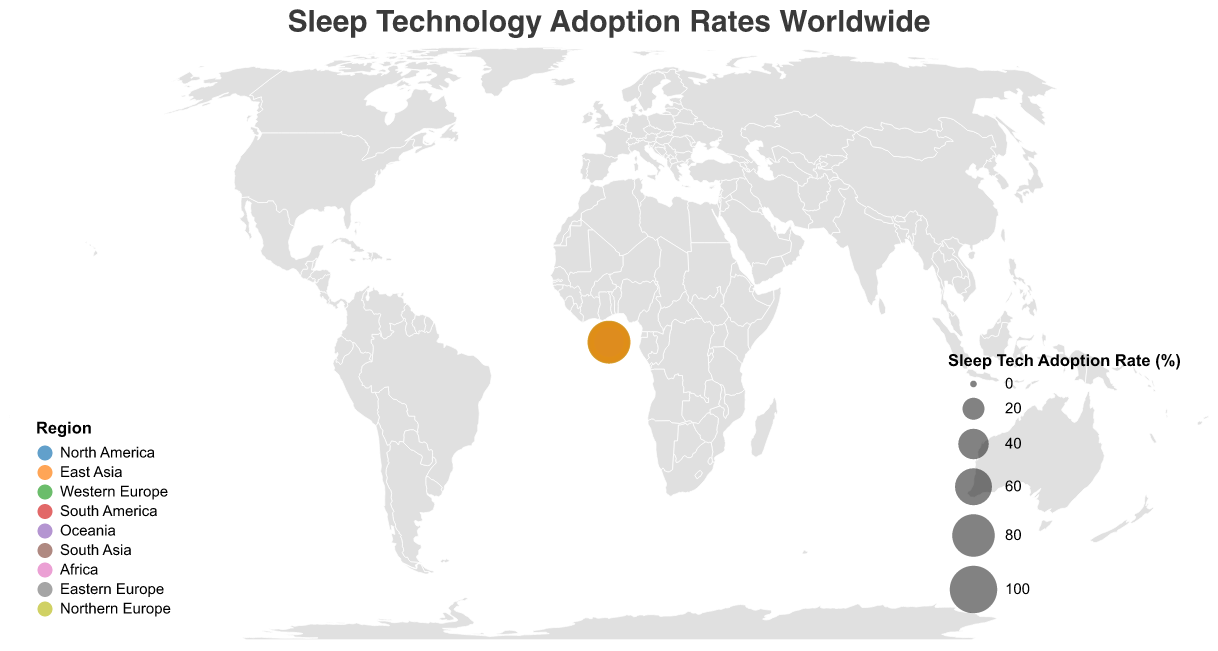What is the title of the figure? The title is located at the top of the figure and defines the main subject of the data visualization.
Answer: Sleep Technology Adoption Rates Worldwide Which country has the lowest sleep tech adoption rate? From the figure, identify the country with the smallest circle, as the size of the circle represents the adoption rate.
Answer: South Africa What is the most popular therapy in Japan? Hover or look at the tooltip for Japan displayed on the figure. It indicates the most popular therapy in that specific country.
Answer: Light Therapy How does the sleep tech adoption rate in the United States compare to that in Canada? Compare the size of the circles representing the United States and Canada, or directly compare the adoption rate values from the tooltips. The rates are 78% for the US and 75% for Canada.
Answer: The United States has a slightly higher adoption rate than Canada What is the average sleep tech adoption rate in Western Europe? Calculate the average by summing the adoption rates of Germany (65%), United Kingdom (72%), and France (68%) and dividing by the number of countries. (65 + 72 + 68) / 3 = 205 / 3
Answer: 68.33% Which region has the highest overall sleep tech adoption rate and which country in that region drives this rate? Identify the region with the highest adoption rate by examining the size of the circles relative to their colors. East Asia has the highest overall rates driven primarily by Japan (82%).
Answer: East Asia, driven by Japan Compare the sleep tech adoption rates between the largest and smallest circles on the map. The largest circle represents Japan with an 82% adoption rate, and the smallest circle represents South Africa with a 28% adoption rate. To compare, simply subtract the smaller rate from the larger one: 82% - 28%.
Answer: There is a 54% difference Which therapy is most popular in Western Europe and how many countries in that region prefer different therapies? Hover over the countries in Western Europe and note the most popular therapies. Germany prefers Biofeedback, the United Kingdom prefers Mindfulness-Based Therapy, and France prefers Chronotherapy. This means there are three different therapies preferred in Western Europe.
Answer: Mindfulness-Based Therapy, 3 countries prefer different therapies What trend can be observed about sleep tech adoption rate regarding the popularity of Cognitive Behavioral Therapy for Insomnia? Identify countries that use Cognitive Behavioral Therapy for Insomnia as the most popular therapy and check their adoption rates. The United States has a 78% rate. This highlights that regions with Cognitive Behavioral Therapy for Insomnia may observe higher adoption rates.
Answer: Countries with Cognitive Behavioral Therapy for Insomnia tend to have high adoption rates What regions have all their countries adopting a different sleep therapy and what are they? Examine the tooltip for each country and compare their regions. North America (US, Canada, Mexico) has all its countries with different therapies - Cognitive Behavioral Therapy for Insomnia, Sleep Hygiene Education, Progressive Muscle Relaxation.
Answer: North America 